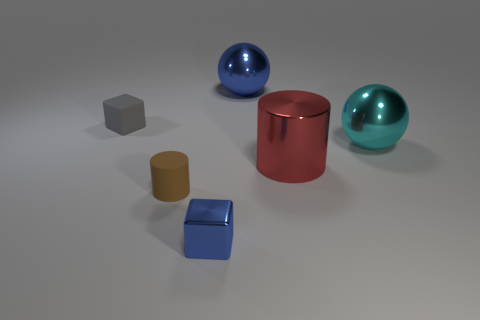Is there any other thing that is the same size as the blue metallic cube?
Provide a short and direct response. Yes. What color is the cylinder to the right of the large object that is on the left side of the metallic cylinder that is to the right of the small rubber cylinder?
Provide a succinct answer. Red. Is the color of the cube behind the blue metal block the same as the ball to the left of the large red metallic cylinder?
Make the answer very short. No. Are there any other things that are the same color as the tiny shiny block?
Ensure brevity in your answer.  Yes. Are there fewer big blue shiny spheres that are behind the blue sphere than small cyan metallic balls?
Your answer should be compact. No. What number of large red blocks are there?
Keep it short and to the point. 0. There is a small brown object; is it the same shape as the blue metal thing in front of the cyan object?
Provide a succinct answer. No. Are there fewer metallic cubes behind the large cyan metal thing than large cylinders in front of the red thing?
Offer a very short reply. No. Is there any other thing that has the same shape as the small shiny object?
Your response must be concise. Yes. Is the tiny brown object the same shape as the red metallic thing?
Your answer should be very brief. Yes. 